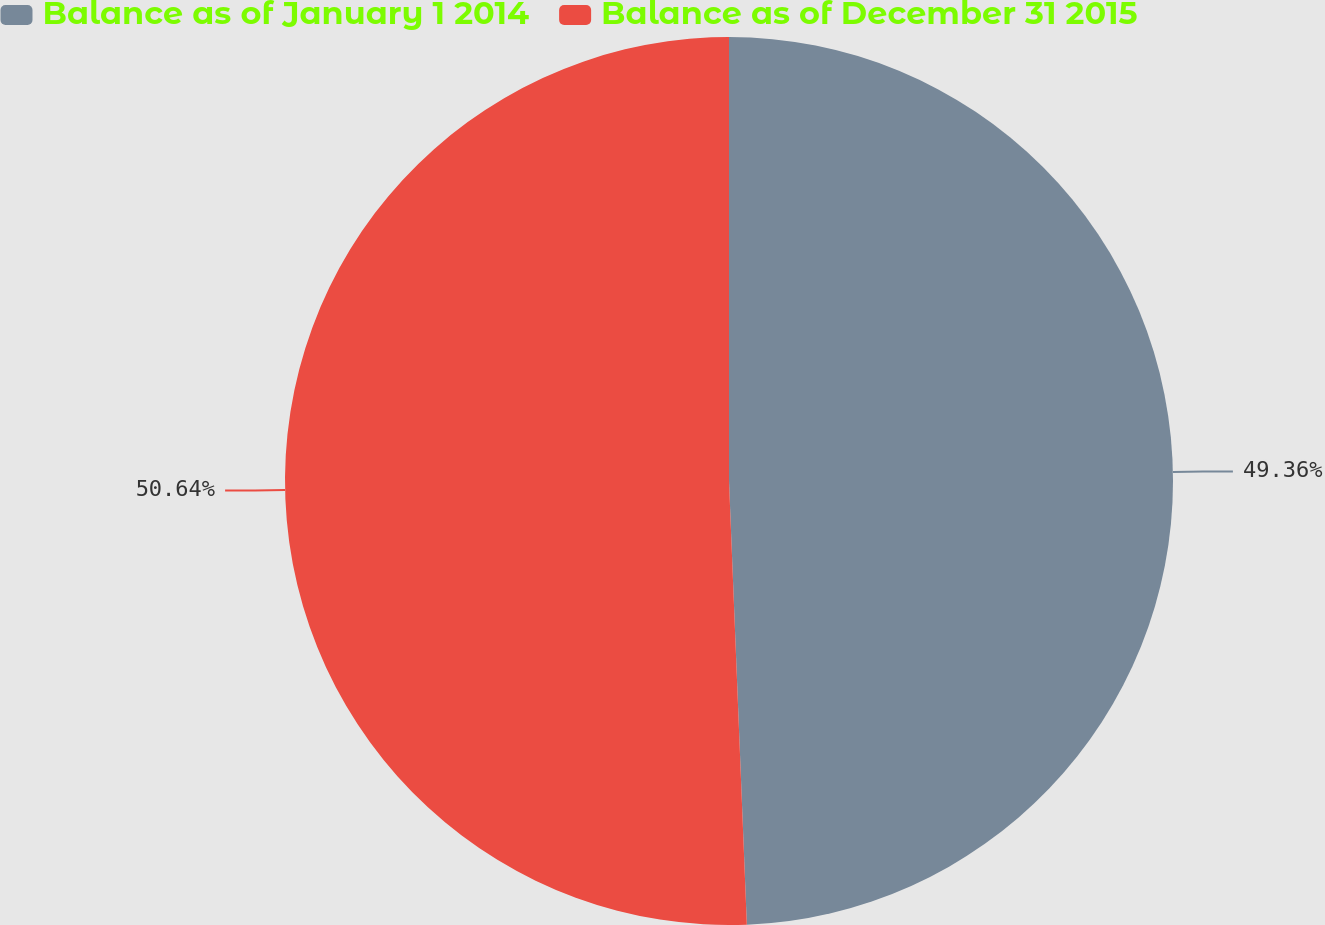Convert chart. <chart><loc_0><loc_0><loc_500><loc_500><pie_chart><fcel>Balance as of January 1 2014<fcel>Balance as of December 31 2015<nl><fcel>49.36%<fcel>50.64%<nl></chart> 